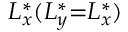<formula> <loc_0><loc_0><loc_500><loc_500>L _ { x } ^ { * } ( L _ { y } ^ { * } { = } L _ { x } ^ { * } )</formula> 